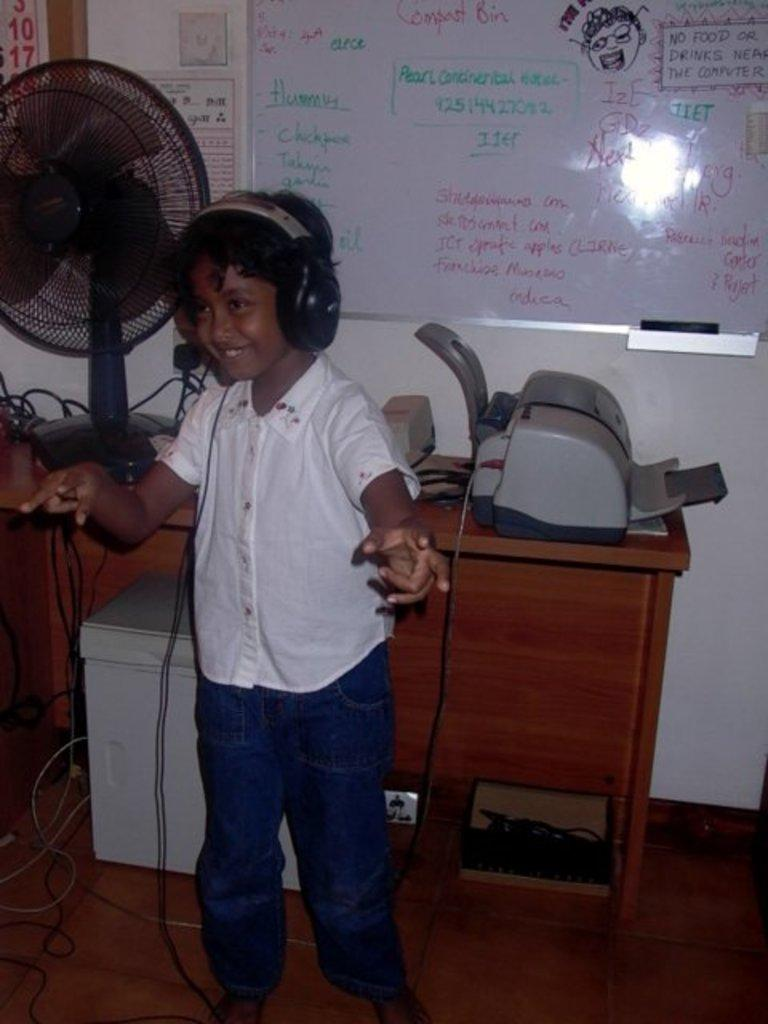Who is in the image? There is a boy in the image. What is the boy doing in the image? The boy is smiling in the image. What is the boy wearing in the image? The boy is wearing a headset in the image. What can be seen in the background of the image? There is a board and a printer in the background of the image. How does the boy transport the bead in the image? There is no bead present in the image, so it cannot be transported by the boy. 